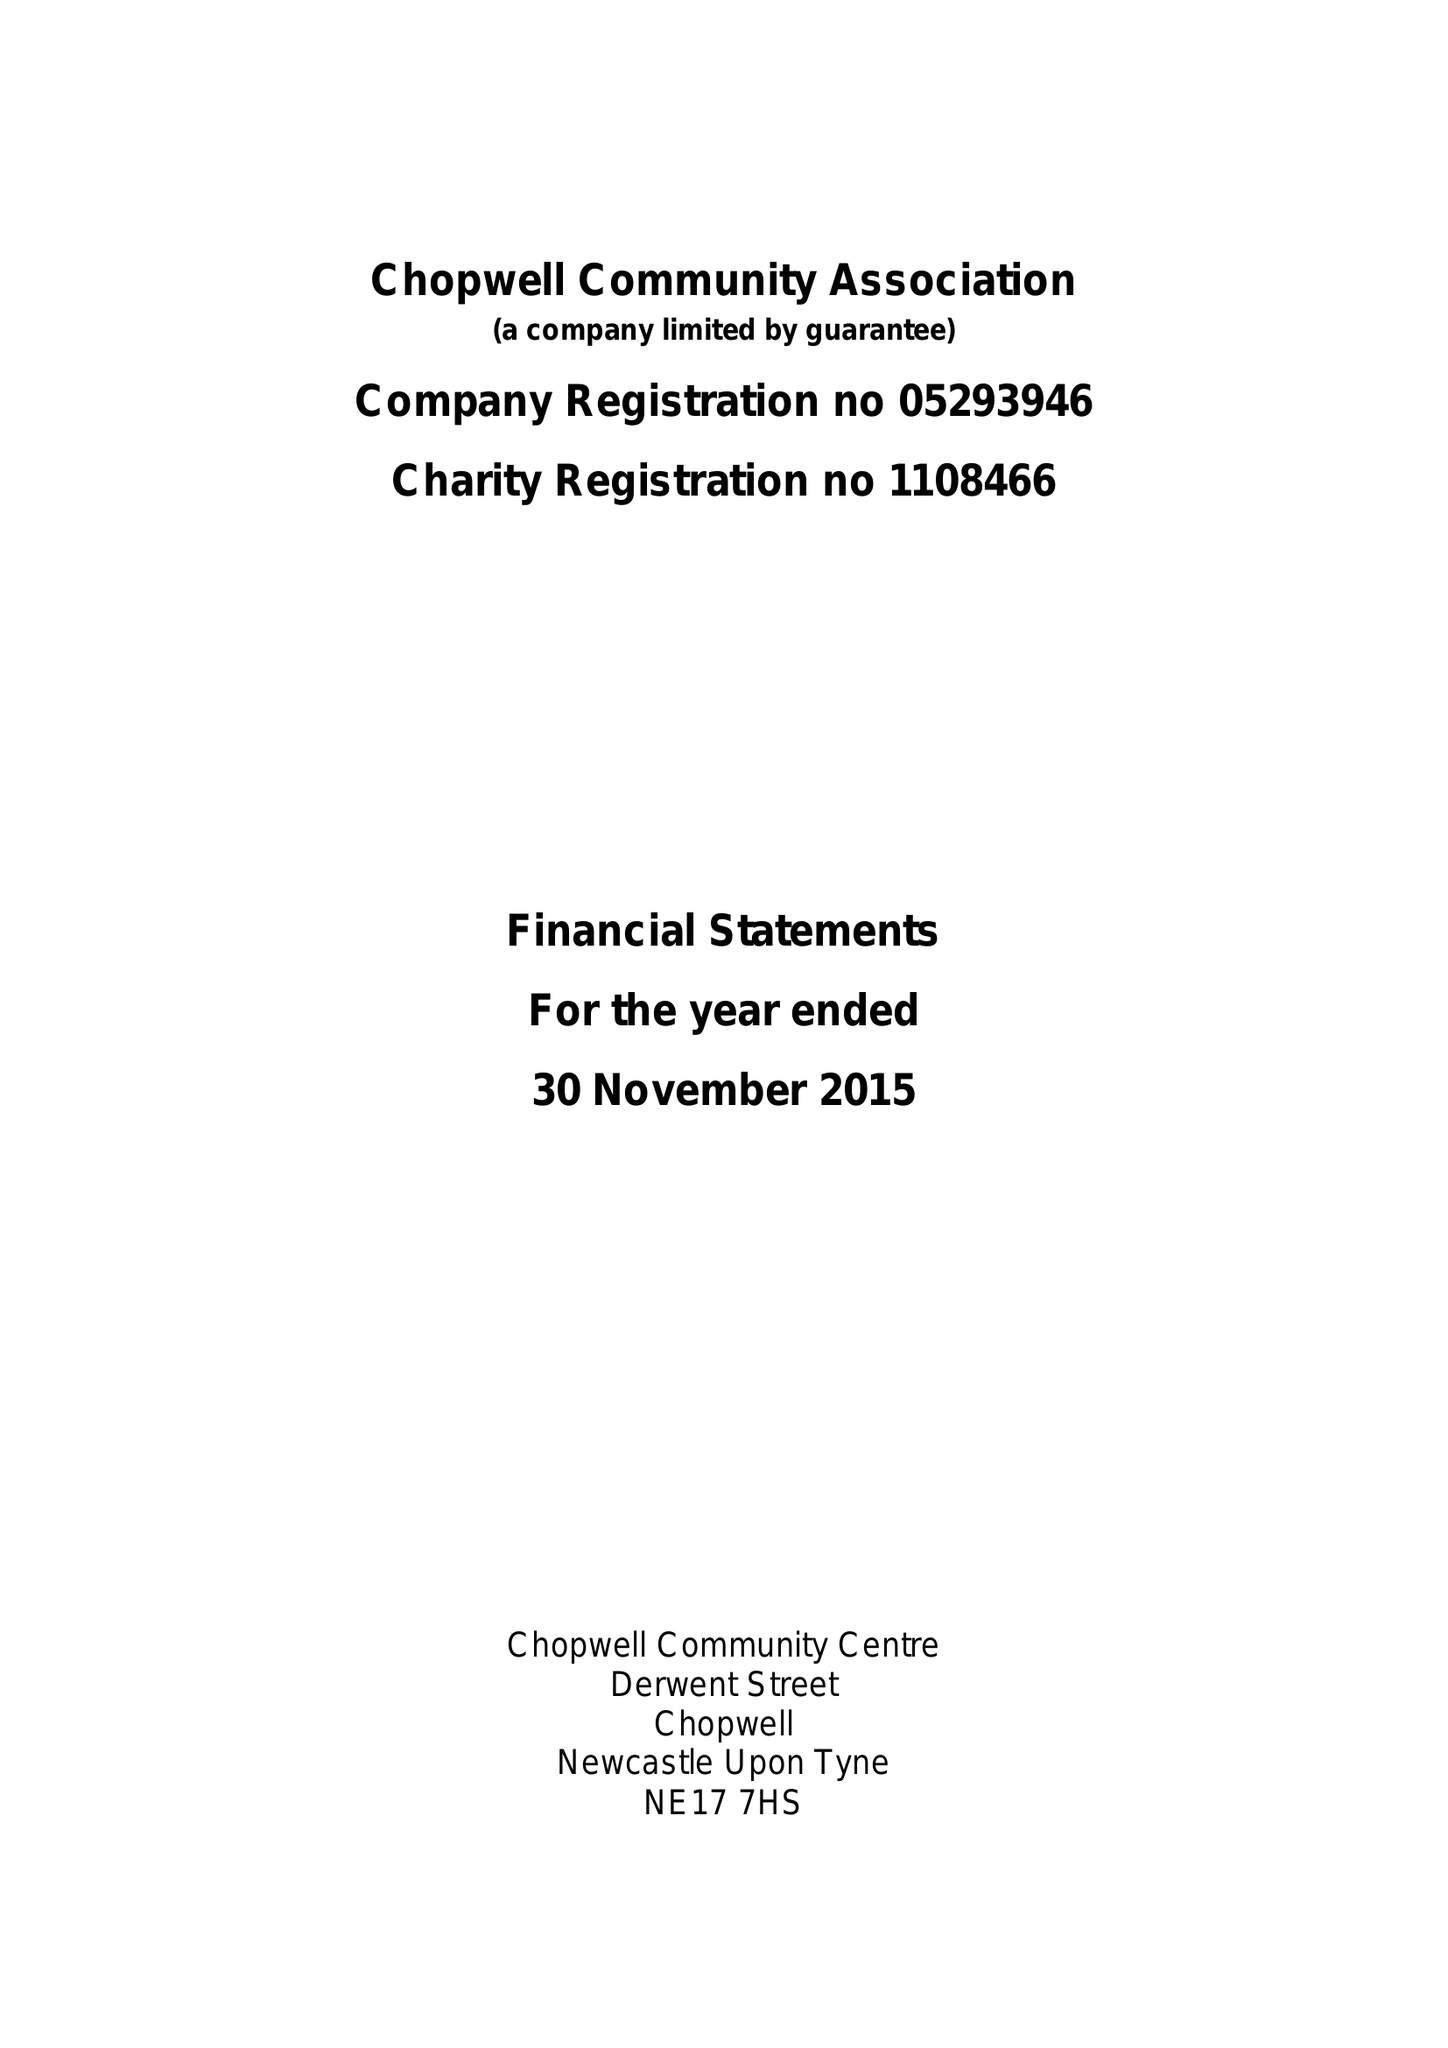What is the value for the address__post_town?
Answer the question using a single word or phrase. NEWCASTLE UPON TYNE 